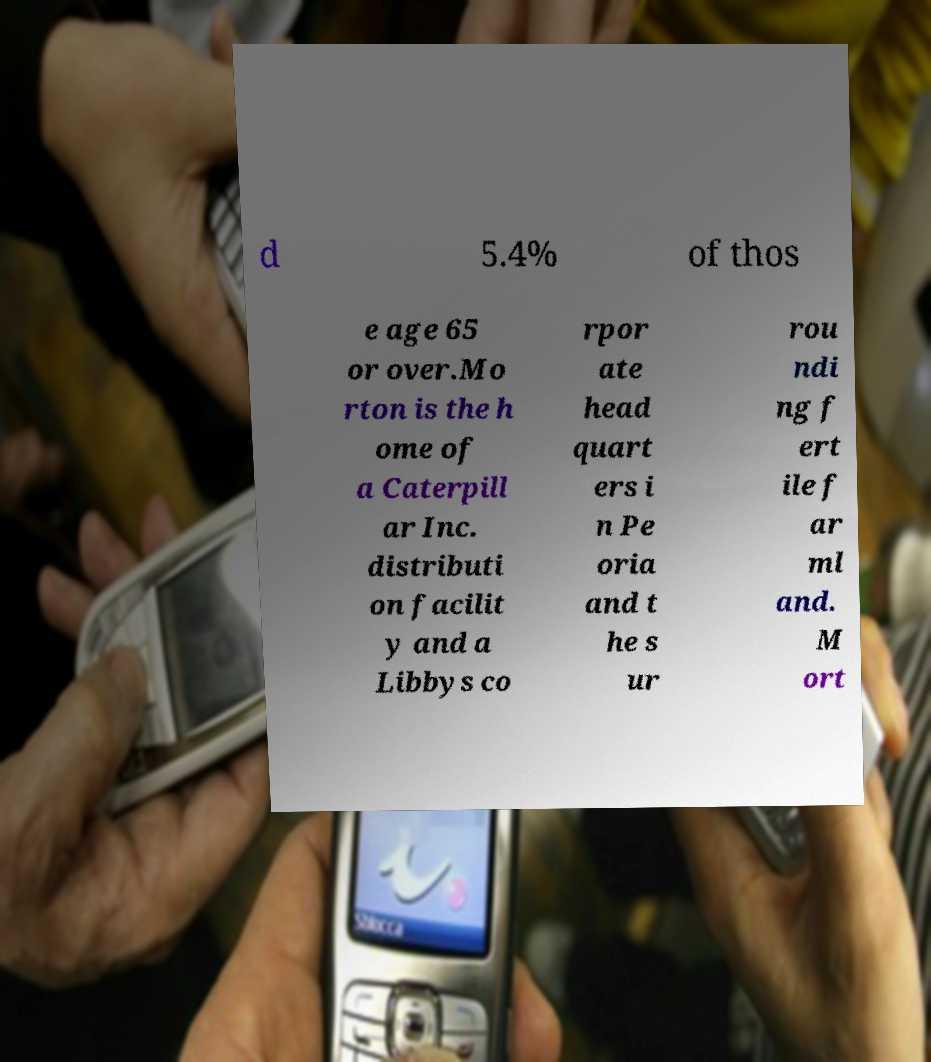I need the written content from this picture converted into text. Can you do that? d 5.4% of thos e age 65 or over.Mo rton is the h ome of a Caterpill ar Inc. distributi on facilit y and a Libbys co rpor ate head quart ers i n Pe oria and t he s ur rou ndi ng f ert ile f ar ml and. M ort 